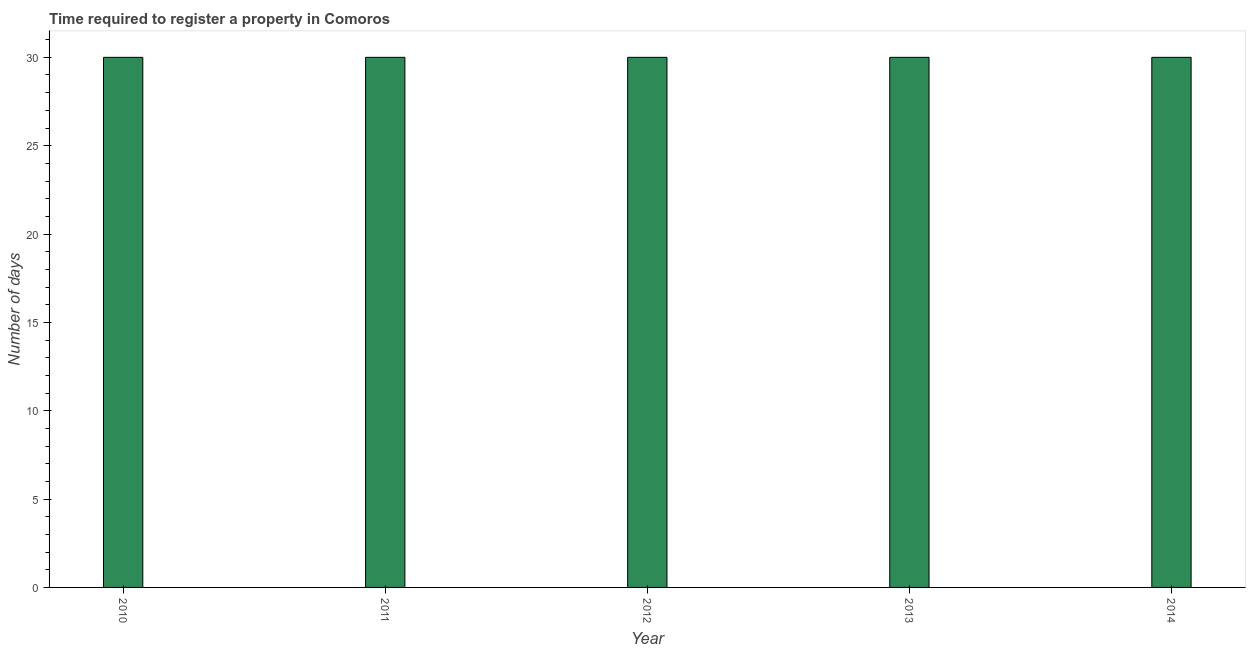Does the graph contain grids?
Keep it short and to the point. No. What is the title of the graph?
Keep it short and to the point. Time required to register a property in Comoros. What is the label or title of the Y-axis?
Provide a succinct answer. Number of days. What is the number of days required to register property in 2010?
Offer a very short reply. 30. Across all years, what is the maximum number of days required to register property?
Your answer should be compact. 30. In which year was the number of days required to register property maximum?
Make the answer very short. 2010. In which year was the number of days required to register property minimum?
Provide a succinct answer. 2010. What is the sum of the number of days required to register property?
Ensure brevity in your answer.  150. What is the average number of days required to register property per year?
Give a very brief answer. 30. What is the ratio of the number of days required to register property in 2012 to that in 2013?
Provide a succinct answer. 1. Is the number of days required to register property in 2013 less than that in 2014?
Provide a succinct answer. No. Is the sum of the number of days required to register property in 2013 and 2014 greater than the maximum number of days required to register property across all years?
Give a very brief answer. Yes. Are all the bars in the graph horizontal?
Make the answer very short. No. What is the difference between two consecutive major ticks on the Y-axis?
Make the answer very short. 5. What is the Number of days in 2012?
Offer a terse response. 30. What is the Number of days of 2014?
Offer a terse response. 30. What is the difference between the Number of days in 2010 and 2013?
Offer a very short reply. 0. What is the difference between the Number of days in 2010 and 2014?
Provide a short and direct response. 0. What is the difference between the Number of days in 2013 and 2014?
Keep it short and to the point. 0. What is the ratio of the Number of days in 2010 to that in 2011?
Provide a short and direct response. 1. What is the ratio of the Number of days in 2010 to that in 2012?
Your response must be concise. 1. What is the ratio of the Number of days in 2010 to that in 2013?
Ensure brevity in your answer.  1. What is the ratio of the Number of days in 2011 to that in 2014?
Make the answer very short. 1. What is the ratio of the Number of days in 2012 to that in 2013?
Your answer should be very brief. 1. What is the ratio of the Number of days in 2012 to that in 2014?
Your answer should be very brief. 1. What is the ratio of the Number of days in 2013 to that in 2014?
Provide a short and direct response. 1. 